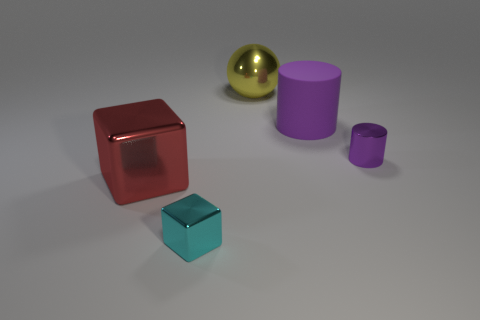How many things are large red matte balls or small metallic things?
Make the answer very short. 2. What is the big object to the right of the large shiny object on the right side of the red object made of?
Offer a very short reply. Rubber. Is there a small metal cube of the same color as the sphere?
Your answer should be very brief. No. What color is the metallic cylinder that is the same size as the cyan metal cube?
Provide a succinct answer. Purple. What is the material of the block that is in front of the large thing that is left of the big yellow ball that is behind the small cyan thing?
Give a very brief answer. Metal. There is a tiny metallic block; does it have the same color as the large shiny thing that is to the left of the large shiny ball?
Your answer should be compact. No. How many things are either cylinders that are left of the tiny purple metal cylinder or large metal things that are behind the large purple matte cylinder?
Give a very brief answer. 2. There is a purple object on the left side of the small object that is behind the big red object; what is its shape?
Keep it short and to the point. Cylinder. Is there a large purple block that has the same material as the small purple thing?
Ensure brevity in your answer.  No. The big thing that is the same shape as the tiny cyan shiny object is what color?
Make the answer very short. Red. 